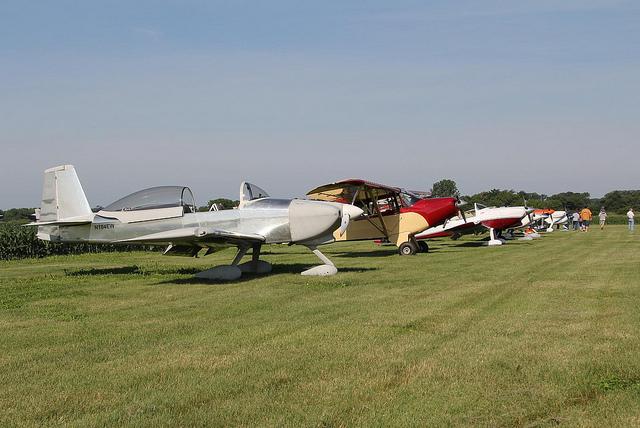Is it at an airport?
Concise answer only. No. Are the planes flying?
Concise answer only. No. What color is the first plane?
Write a very short answer. Silver. Are these planes on display?
Be succinct. Yes. Are there any chairs in the picture?
Keep it brief. No. What kind of vehicle can be seen in this photo?
Answer briefly. Airplane. 